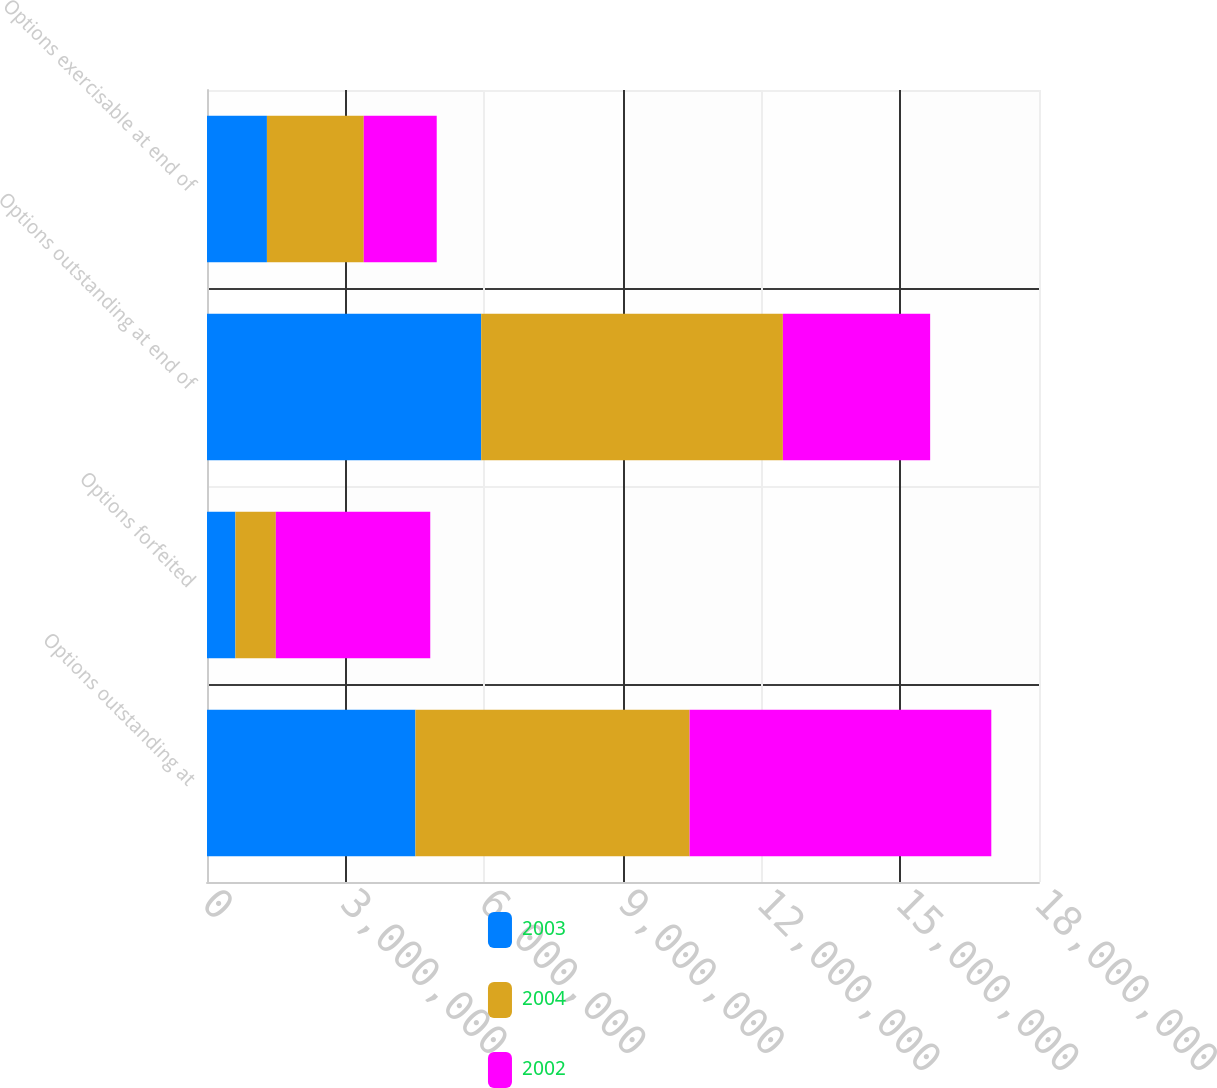Convert chart. <chart><loc_0><loc_0><loc_500><loc_500><stacked_bar_chart><ecel><fcel>Options outstanding at<fcel>Options forfeited<fcel>Options outstanding at end of<fcel>Options exercisable at end of<nl><fcel>2003<fcel>4.50906e+06<fcel>614000<fcel>5.93206e+06<fcel>1.29661e+06<nl><fcel>2004<fcel>5.93206e+06<fcel>875000<fcel>6.52706e+06<fcel>2.09462e+06<nl><fcel>2002<fcel>6.52706e+06<fcel>3.34106e+06<fcel>3.186e+06<fcel>1.5788e+06<nl></chart> 